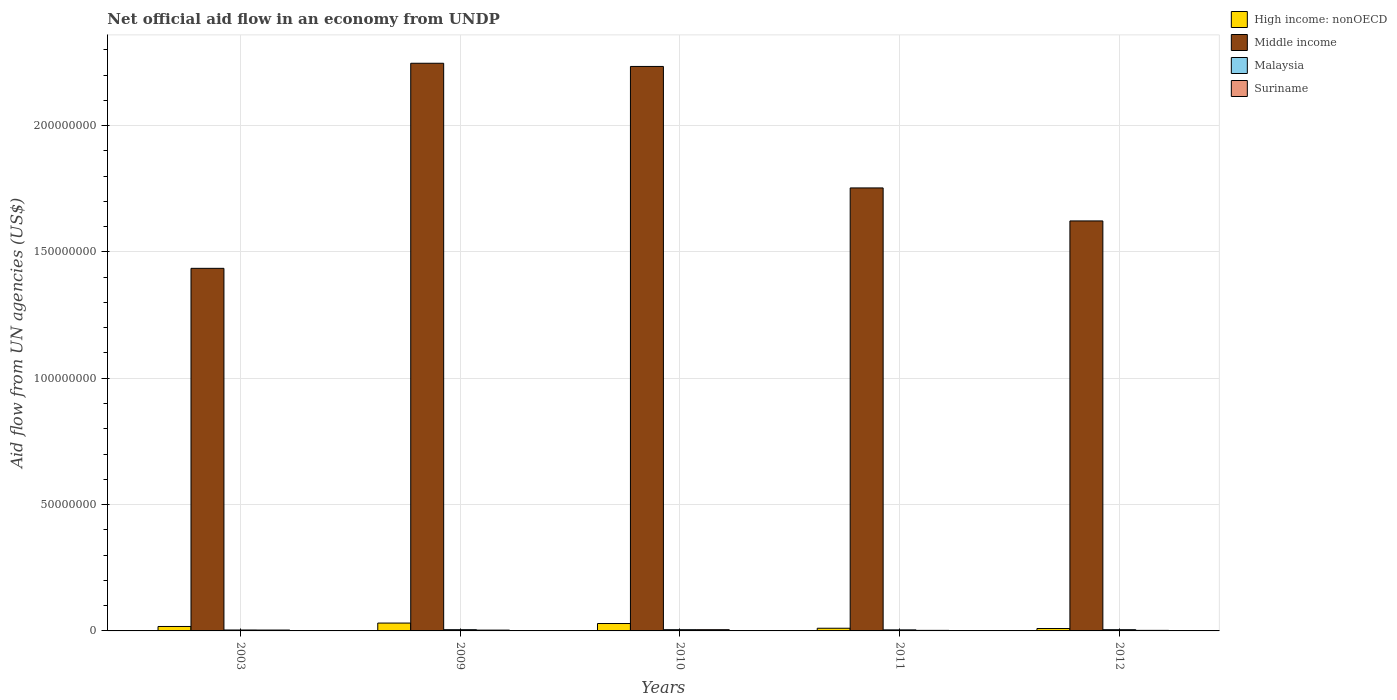How many different coloured bars are there?
Your answer should be very brief. 4. How many groups of bars are there?
Provide a succinct answer. 5. How many bars are there on the 2nd tick from the left?
Provide a short and direct response. 4. How many bars are there on the 1st tick from the right?
Provide a short and direct response. 4. What is the net official aid flow in High income: nonOECD in 2011?
Offer a very short reply. 1.06e+06. Across all years, what is the maximum net official aid flow in Middle income?
Offer a very short reply. 2.25e+08. Across all years, what is the minimum net official aid flow in Middle income?
Ensure brevity in your answer.  1.44e+08. In which year was the net official aid flow in High income: nonOECD minimum?
Your answer should be very brief. 2012. What is the total net official aid flow in Suriname in the graph?
Offer a very short reply. 1.59e+06. What is the difference between the net official aid flow in Suriname in 2011 and that in 2012?
Your answer should be compact. 0. What is the average net official aid flow in Suriname per year?
Your answer should be very brief. 3.18e+05. In the year 2003, what is the difference between the net official aid flow in Suriname and net official aid flow in Middle income?
Your answer should be compact. -1.43e+08. What is the ratio of the net official aid flow in High income: nonOECD in 2003 to that in 2010?
Your response must be concise. 0.6. Is the net official aid flow in Malaysia in 2003 less than that in 2009?
Offer a very short reply. Yes. Is the difference between the net official aid flow in Suriname in 2011 and 2012 greater than the difference between the net official aid flow in Middle income in 2011 and 2012?
Your answer should be very brief. No. What is the difference between the highest and the second highest net official aid flow in Middle income?
Ensure brevity in your answer.  1.26e+06. What is the difference between the highest and the lowest net official aid flow in Middle income?
Offer a terse response. 8.12e+07. In how many years, is the net official aid flow in Middle income greater than the average net official aid flow in Middle income taken over all years?
Ensure brevity in your answer.  2. Is the sum of the net official aid flow in Suriname in 2009 and 2011 greater than the maximum net official aid flow in Malaysia across all years?
Give a very brief answer. Yes. What does the 1st bar from the left in 2010 represents?
Offer a terse response. High income: nonOECD. What does the 2nd bar from the right in 2012 represents?
Make the answer very short. Malaysia. Is it the case that in every year, the sum of the net official aid flow in Suriname and net official aid flow in Middle income is greater than the net official aid flow in Malaysia?
Your answer should be very brief. Yes. Are all the bars in the graph horizontal?
Offer a very short reply. No. Are the values on the major ticks of Y-axis written in scientific E-notation?
Ensure brevity in your answer.  No. Does the graph contain any zero values?
Your response must be concise. No. How many legend labels are there?
Give a very brief answer. 4. How are the legend labels stacked?
Keep it short and to the point. Vertical. What is the title of the graph?
Give a very brief answer. Net official aid flow in an economy from UNDP. Does "Ireland" appear as one of the legend labels in the graph?
Your answer should be compact. No. What is the label or title of the Y-axis?
Provide a short and direct response. Aid flow from UN agencies (US$). What is the Aid flow from UN agencies (US$) in High income: nonOECD in 2003?
Provide a short and direct response. 1.76e+06. What is the Aid flow from UN agencies (US$) in Middle income in 2003?
Ensure brevity in your answer.  1.44e+08. What is the Aid flow from UN agencies (US$) in Suriname in 2003?
Make the answer very short. 3.40e+05. What is the Aid flow from UN agencies (US$) of High income: nonOECD in 2009?
Your answer should be very brief. 3.11e+06. What is the Aid flow from UN agencies (US$) in Middle income in 2009?
Keep it short and to the point. 2.25e+08. What is the Aid flow from UN agencies (US$) of Suriname in 2009?
Provide a succinct answer. 3.20e+05. What is the Aid flow from UN agencies (US$) of High income: nonOECD in 2010?
Provide a succinct answer. 2.93e+06. What is the Aid flow from UN agencies (US$) of Middle income in 2010?
Offer a terse response. 2.23e+08. What is the Aid flow from UN agencies (US$) of Malaysia in 2010?
Your answer should be compact. 4.90e+05. What is the Aid flow from UN agencies (US$) in Suriname in 2010?
Keep it short and to the point. 4.90e+05. What is the Aid flow from UN agencies (US$) of High income: nonOECD in 2011?
Keep it short and to the point. 1.06e+06. What is the Aid flow from UN agencies (US$) of Middle income in 2011?
Offer a very short reply. 1.75e+08. What is the Aid flow from UN agencies (US$) of Malaysia in 2011?
Provide a succinct answer. 4.20e+05. What is the Aid flow from UN agencies (US$) of High income: nonOECD in 2012?
Give a very brief answer. 9.50e+05. What is the Aid flow from UN agencies (US$) in Middle income in 2012?
Keep it short and to the point. 1.62e+08. Across all years, what is the maximum Aid flow from UN agencies (US$) in High income: nonOECD?
Keep it short and to the point. 3.11e+06. Across all years, what is the maximum Aid flow from UN agencies (US$) in Middle income?
Provide a succinct answer. 2.25e+08. Across all years, what is the maximum Aid flow from UN agencies (US$) of Malaysia?
Offer a very short reply. 4.90e+05. Across all years, what is the maximum Aid flow from UN agencies (US$) of Suriname?
Your answer should be very brief. 4.90e+05. Across all years, what is the minimum Aid flow from UN agencies (US$) of High income: nonOECD?
Provide a short and direct response. 9.50e+05. Across all years, what is the minimum Aid flow from UN agencies (US$) in Middle income?
Keep it short and to the point. 1.44e+08. Across all years, what is the minimum Aid flow from UN agencies (US$) in Malaysia?
Your response must be concise. 3.70e+05. What is the total Aid flow from UN agencies (US$) in High income: nonOECD in the graph?
Provide a short and direct response. 9.81e+06. What is the total Aid flow from UN agencies (US$) of Middle income in the graph?
Provide a succinct answer. 9.29e+08. What is the total Aid flow from UN agencies (US$) in Malaysia in the graph?
Give a very brief answer. 2.26e+06. What is the total Aid flow from UN agencies (US$) in Suriname in the graph?
Ensure brevity in your answer.  1.59e+06. What is the difference between the Aid flow from UN agencies (US$) of High income: nonOECD in 2003 and that in 2009?
Provide a short and direct response. -1.35e+06. What is the difference between the Aid flow from UN agencies (US$) of Middle income in 2003 and that in 2009?
Offer a very short reply. -8.12e+07. What is the difference between the Aid flow from UN agencies (US$) in Suriname in 2003 and that in 2009?
Keep it short and to the point. 2.00e+04. What is the difference between the Aid flow from UN agencies (US$) in High income: nonOECD in 2003 and that in 2010?
Provide a succinct answer. -1.17e+06. What is the difference between the Aid flow from UN agencies (US$) of Middle income in 2003 and that in 2010?
Provide a succinct answer. -7.99e+07. What is the difference between the Aid flow from UN agencies (US$) in Malaysia in 2003 and that in 2010?
Provide a short and direct response. -1.20e+05. What is the difference between the Aid flow from UN agencies (US$) in Middle income in 2003 and that in 2011?
Your response must be concise. -3.18e+07. What is the difference between the Aid flow from UN agencies (US$) in Malaysia in 2003 and that in 2011?
Make the answer very short. -5.00e+04. What is the difference between the Aid flow from UN agencies (US$) of Suriname in 2003 and that in 2011?
Provide a short and direct response. 1.20e+05. What is the difference between the Aid flow from UN agencies (US$) of High income: nonOECD in 2003 and that in 2012?
Your answer should be compact. 8.10e+05. What is the difference between the Aid flow from UN agencies (US$) of Middle income in 2003 and that in 2012?
Provide a succinct answer. -1.88e+07. What is the difference between the Aid flow from UN agencies (US$) in Malaysia in 2003 and that in 2012?
Give a very brief answer. -1.20e+05. What is the difference between the Aid flow from UN agencies (US$) of Suriname in 2003 and that in 2012?
Your answer should be very brief. 1.20e+05. What is the difference between the Aid flow from UN agencies (US$) in High income: nonOECD in 2009 and that in 2010?
Your answer should be compact. 1.80e+05. What is the difference between the Aid flow from UN agencies (US$) of Middle income in 2009 and that in 2010?
Make the answer very short. 1.26e+06. What is the difference between the Aid flow from UN agencies (US$) of Suriname in 2009 and that in 2010?
Offer a terse response. -1.70e+05. What is the difference between the Aid flow from UN agencies (US$) in High income: nonOECD in 2009 and that in 2011?
Provide a short and direct response. 2.05e+06. What is the difference between the Aid flow from UN agencies (US$) in Middle income in 2009 and that in 2011?
Make the answer very short. 4.93e+07. What is the difference between the Aid flow from UN agencies (US$) in Malaysia in 2009 and that in 2011?
Keep it short and to the point. 7.00e+04. What is the difference between the Aid flow from UN agencies (US$) in Suriname in 2009 and that in 2011?
Offer a terse response. 1.00e+05. What is the difference between the Aid flow from UN agencies (US$) in High income: nonOECD in 2009 and that in 2012?
Provide a succinct answer. 2.16e+06. What is the difference between the Aid flow from UN agencies (US$) in Middle income in 2009 and that in 2012?
Ensure brevity in your answer.  6.24e+07. What is the difference between the Aid flow from UN agencies (US$) of Malaysia in 2009 and that in 2012?
Offer a very short reply. 0. What is the difference between the Aid flow from UN agencies (US$) of Suriname in 2009 and that in 2012?
Provide a succinct answer. 1.00e+05. What is the difference between the Aid flow from UN agencies (US$) of High income: nonOECD in 2010 and that in 2011?
Provide a succinct answer. 1.87e+06. What is the difference between the Aid flow from UN agencies (US$) in Middle income in 2010 and that in 2011?
Provide a succinct answer. 4.81e+07. What is the difference between the Aid flow from UN agencies (US$) of Malaysia in 2010 and that in 2011?
Offer a terse response. 7.00e+04. What is the difference between the Aid flow from UN agencies (US$) in High income: nonOECD in 2010 and that in 2012?
Ensure brevity in your answer.  1.98e+06. What is the difference between the Aid flow from UN agencies (US$) in Middle income in 2010 and that in 2012?
Provide a short and direct response. 6.11e+07. What is the difference between the Aid flow from UN agencies (US$) of Malaysia in 2010 and that in 2012?
Keep it short and to the point. 0. What is the difference between the Aid flow from UN agencies (US$) in Suriname in 2010 and that in 2012?
Keep it short and to the point. 2.70e+05. What is the difference between the Aid flow from UN agencies (US$) in Middle income in 2011 and that in 2012?
Your answer should be compact. 1.31e+07. What is the difference between the Aid flow from UN agencies (US$) in Malaysia in 2011 and that in 2012?
Ensure brevity in your answer.  -7.00e+04. What is the difference between the Aid flow from UN agencies (US$) of Suriname in 2011 and that in 2012?
Your response must be concise. 0. What is the difference between the Aid flow from UN agencies (US$) of High income: nonOECD in 2003 and the Aid flow from UN agencies (US$) of Middle income in 2009?
Provide a short and direct response. -2.23e+08. What is the difference between the Aid flow from UN agencies (US$) in High income: nonOECD in 2003 and the Aid flow from UN agencies (US$) in Malaysia in 2009?
Provide a succinct answer. 1.27e+06. What is the difference between the Aid flow from UN agencies (US$) of High income: nonOECD in 2003 and the Aid flow from UN agencies (US$) of Suriname in 2009?
Keep it short and to the point. 1.44e+06. What is the difference between the Aid flow from UN agencies (US$) of Middle income in 2003 and the Aid flow from UN agencies (US$) of Malaysia in 2009?
Offer a terse response. 1.43e+08. What is the difference between the Aid flow from UN agencies (US$) in Middle income in 2003 and the Aid flow from UN agencies (US$) in Suriname in 2009?
Give a very brief answer. 1.43e+08. What is the difference between the Aid flow from UN agencies (US$) of Malaysia in 2003 and the Aid flow from UN agencies (US$) of Suriname in 2009?
Provide a short and direct response. 5.00e+04. What is the difference between the Aid flow from UN agencies (US$) of High income: nonOECD in 2003 and the Aid flow from UN agencies (US$) of Middle income in 2010?
Provide a succinct answer. -2.22e+08. What is the difference between the Aid flow from UN agencies (US$) in High income: nonOECD in 2003 and the Aid flow from UN agencies (US$) in Malaysia in 2010?
Provide a succinct answer. 1.27e+06. What is the difference between the Aid flow from UN agencies (US$) in High income: nonOECD in 2003 and the Aid flow from UN agencies (US$) in Suriname in 2010?
Your response must be concise. 1.27e+06. What is the difference between the Aid flow from UN agencies (US$) of Middle income in 2003 and the Aid flow from UN agencies (US$) of Malaysia in 2010?
Provide a short and direct response. 1.43e+08. What is the difference between the Aid flow from UN agencies (US$) of Middle income in 2003 and the Aid flow from UN agencies (US$) of Suriname in 2010?
Offer a terse response. 1.43e+08. What is the difference between the Aid flow from UN agencies (US$) in Malaysia in 2003 and the Aid flow from UN agencies (US$) in Suriname in 2010?
Offer a terse response. -1.20e+05. What is the difference between the Aid flow from UN agencies (US$) in High income: nonOECD in 2003 and the Aid flow from UN agencies (US$) in Middle income in 2011?
Your response must be concise. -1.74e+08. What is the difference between the Aid flow from UN agencies (US$) of High income: nonOECD in 2003 and the Aid flow from UN agencies (US$) of Malaysia in 2011?
Offer a terse response. 1.34e+06. What is the difference between the Aid flow from UN agencies (US$) of High income: nonOECD in 2003 and the Aid flow from UN agencies (US$) of Suriname in 2011?
Offer a terse response. 1.54e+06. What is the difference between the Aid flow from UN agencies (US$) in Middle income in 2003 and the Aid flow from UN agencies (US$) in Malaysia in 2011?
Provide a succinct answer. 1.43e+08. What is the difference between the Aid flow from UN agencies (US$) in Middle income in 2003 and the Aid flow from UN agencies (US$) in Suriname in 2011?
Give a very brief answer. 1.43e+08. What is the difference between the Aid flow from UN agencies (US$) in High income: nonOECD in 2003 and the Aid flow from UN agencies (US$) in Middle income in 2012?
Make the answer very short. -1.60e+08. What is the difference between the Aid flow from UN agencies (US$) in High income: nonOECD in 2003 and the Aid flow from UN agencies (US$) in Malaysia in 2012?
Your response must be concise. 1.27e+06. What is the difference between the Aid flow from UN agencies (US$) in High income: nonOECD in 2003 and the Aid flow from UN agencies (US$) in Suriname in 2012?
Offer a terse response. 1.54e+06. What is the difference between the Aid flow from UN agencies (US$) in Middle income in 2003 and the Aid flow from UN agencies (US$) in Malaysia in 2012?
Provide a short and direct response. 1.43e+08. What is the difference between the Aid flow from UN agencies (US$) of Middle income in 2003 and the Aid flow from UN agencies (US$) of Suriname in 2012?
Offer a very short reply. 1.43e+08. What is the difference between the Aid flow from UN agencies (US$) of High income: nonOECD in 2009 and the Aid flow from UN agencies (US$) of Middle income in 2010?
Make the answer very short. -2.20e+08. What is the difference between the Aid flow from UN agencies (US$) of High income: nonOECD in 2009 and the Aid flow from UN agencies (US$) of Malaysia in 2010?
Your answer should be very brief. 2.62e+06. What is the difference between the Aid flow from UN agencies (US$) of High income: nonOECD in 2009 and the Aid flow from UN agencies (US$) of Suriname in 2010?
Offer a terse response. 2.62e+06. What is the difference between the Aid flow from UN agencies (US$) of Middle income in 2009 and the Aid flow from UN agencies (US$) of Malaysia in 2010?
Keep it short and to the point. 2.24e+08. What is the difference between the Aid flow from UN agencies (US$) of Middle income in 2009 and the Aid flow from UN agencies (US$) of Suriname in 2010?
Offer a very short reply. 2.24e+08. What is the difference between the Aid flow from UN agencies (US$) of High income: nonOECD in 2009 and the Aid flow from UN agencies (US$) of Middle income in 2011?
Offer a very short reply. -1.72e+08. What is the difference between the Aid flow from UN agencies (US$) of High income: nonOECD in 2009 and the Aid flow from UN agencies (US$) of Malaysia in 2011?
Provide a succinct answer. 2.69e+06. What is the difference between the Aid flow from UN agencies (US$) in High income: nonOECD in 2009 and the Aid flow from UN agencies (US$) in Suriname in 2011?
Your response must be concise. 2.89e+06. What is the difference between the Aid flow from UN agencies (US$) in Middle income in 2009 and the Aid flow from UN agencies (US$) in Malaysia in 2011?
Offer a terse response. 2.24e+08. What is the difference between the Aid flow from UN agencies (US$) in Middle income in 2009 and the Aid flow from UN agencies (US$) in Suriname in 2011?
Offer a terse response. 2.24e+08. What is the difference between the Aid flow from UN agencies (US$) in High income: nonOECD in 2009 and the Aid flow from UN agencies (US$) in Middle income in 2012?
Offer a very short reply. -1.59e+08. What is the difference between the Aid flow from UN agencies (US$) of High income: nonOECD in 2009 and the Aid flow from UN agencies (US$) of Malaysia in 2012?
Your response must be concise. 2.62e+06. What is the difference between the Aid flow from UN agencies (US$) of High income: nonOECD in 2009 and the Aid flow from UN agencies (US$) of Suriname in 2012?
Provide a short and direct response. 2.89e+06. What is the difference between the Aid flow from UN agencies (US$) in Middle income in 2009 and the Aid flow from UN agencies (US$) in Malaysia in 2012?
Provide a succinct answer. 2.24e+08. What is the difference between the Aid flow from UN agencies (US$) of Middle income in 2009 and the Aid flow from UN agencies (US$) of Suriname in 2012?
Your answer should be very brief. 2.24e+08. What is the difference between the Aid flow from UN agencies (US$) of High income: nonOECD in 2010 and the Aid flow from UN agencies (US$) of Middle income in 2011?
Make the answer very short. -1.72e+08. What is the difference between the Aid flow from UN agencies (US$) of High income: nonOECD in 2010 and the Aid flow from UN agencies (US$) of Malaysia in 2011?
Give a very brief answer. 2.51e+06. What is the difference between the Aid flow from UN agencies (US$) in High income: nonOECD in 2010 and the Aid flow from UN agencies (US$) in Suriname in 2011?
Make the answer very short. 2.71e+06. What is the difference between the Aid flow from UN agencies (US$) in Middle income in 2010 and the Aid flow from UN agencies (US$) in Malaysia in 2011?
Make the answer very short. 2.23e+08. What is the difference between the Aid flow from UN agencies (US$) in Middle income in 2010 and the Aid flow from UN agencies (US$) in Suriname in 2011?
Keep it short and to the point. 2.23e+08. What is the difference between the Aid flow from UN agencies (US$) of High income: nonOECD in 2010 and the Aid flow from UN agencies (US$) of Middle income in 2012?
Provide a short and direct response. -1.59e+08. What is the difference between the Aid flow from UN agencies (US$) in High income: nonOECD in 2010 and the Aid flow from UN agencies (US$) in Malaysia in 2012?
Give a very brief answer. 2.44e+06. What is the difference between the Aid flow from UN agencies (US$) of High income: nonOECD in 2010 and the Aid flow from UN agencies (US$) of Suriname in 2012?
Your answer should be compact. 2.71e+06. What is the difference between the Aid flow from UN agencies (US$) in Middle income in 2010 and the Aid flow from UN agencies (US$) in Malaysia in 2012?
Provide a short and direct response. 2.23e+08. What is the difference between the Aid flow from UN agencies (US$) in Middle income in 2010 and the Aid flow from UN agencies (US$) in Suriname in 2012?
Give a very brief answer. 2.23e+08. What is the difference between the Aid flow from UN agencies (US$) of Malaysia in 2010 and the Aid flow from UN agencies (US$) of Suriname in 2012?
Offer a terse response. 2.70e+05. What is the difference between the Aid flow from UN agencies (US$) of High income: nonOECD in 2011 and the Aid flow from UN agencies (US$) of Middle income in 2012?
Give a very brief answer. -1.61e+08. What is the difference between the Aid flow from UN agencies (US$) in High income: nonOECD in 2011 and the Aid flow from UN agencies (US$) in Malaysia in 2012?
Offer a very short reply. 5.70e+05. What is the difference between the Aid flow from UN agencies (US$) in High income: nonOECD in 2011 and the Aid flow from UN agencies (US$) in Suriname in 2012?
Make the answer very short. 8.40e+05. What is the difference between the Aid flow from UN agencies (US$) in Middle income in 2011 and the Aid flow from UN agencies (US$) in Malaysia in 2012?
Your answer should be compact. 1.75e+08. What is the difference between the Aid flow from UN agencies (US$) in Middle income in 2011 and the Aid flow from UN agencies (US$) in Suriname in 2012?
Give a very brief answer. 1.75e+08. What is the difference between the Aid flow from UN agencies (US$) of Malaysia in 2011 and the Aid flow from UN agencies (US$) of Suriname in 2012?
Ensure brevity in your answer.  2.00e+05. What is the average Aid flow from UN agencies (US$) in High income: nonOECD per year?
Keep it short and to the point. 1.96e+06. What is the average Aid flow from UN agencies (US$) of Middle income per year?
Provide a short and direct response. 1.86e+08. What is the average Aid flow from UN agencies (US$) in Malaysia per year?
Provide a succinct answer. 4.52e+05. What is the average Aid flow from UN agencies (US$) in Suriname per year?
Provide a succinct answer. 3.18e+05. In the year 2003, what is the difference between the Aid flow from UN agencies (US$) in High income: nonOECD and Aid flow from UN agencies (US$) in Middle income?
Your answer should be compact. -1.42e+08. In the year 2003, what is the difference between the Aid flow from UN agencies (US$) in High income: nonOECD and Aid flow from UN agencies (US$) in Malaysia?
Give a very brief answer. 1.39e+06. In the year 2003, what is the difference between the Aid flow from UN agencies (US$) of High income: nonOECD and Aid flow from UN agencies (US$) of Suriname?
Offer a terse response. 1.42e+06. In the year 2003, what is the difference between the Aid flow from UN agencies (US$) of Middle income and Aid flow from UN agencies (US$) of Malaysia?
Make the answer very short. 1.43e+08. In the year 2003, what is the difference between the Aid flow from UN agencies (US$) of Middle income and Aid flow from UN agencies (US$) of Suriname?
Make the answer very short. 1.43e+08. In the year 2009, what is the difference between the Aid flow from UN agencies (US$) of High income: nonOECD and Aid flow from UN agencies (US$) of Middle income?
Offer a very short reply. -2.22e+08. In the year 2009, what is the difference between the Aid flow from UN agencies (US$) in High income: nonOECD and Aid flow from UN agencies (US$) in Malaysia?
Make the answer very short. 2.62e+06. In the year 2009, what is the difference between the Aid flow from UN agencies (US$) of High income: nonOECD and Aid flow from UN agencies (US$) of Suriname?
Provide a short and direct response. 2.79e+06. In the year 2009, what is the difference between the Aid flow from UN agencies (US$) of Middle income and Aid flow from UN agencies (US$) of Malaysia?
Give a very brief answer. 2.24e+08. In the year 2009, what is the difference between the Aid flow from UN agencies (US$) of Middle income and Aid flow from UN agencies (US$) of Suriname?
Your answer should be very brief. 2.24e+08. In the year 2009, what is the difference between the Aid flow from UN agencies (US$) of Malaysia and Aid flow from UN agencies (US$) of Suriname?
Keep it short and to the point. 1.70e+05. In the year 2010, what is the difference between the Aid flow from UN agencies (US$) of High income: nonOECD and Aid flow from UN agencies (US$) of Middle income?
Provide a short and direct response. -2.20e+08. In the year 2010, what is the difference between the Aid flow from UN agencies (US$) of High income: nonOECD and Aid flow from UN agencies (US$) of Malaysia?
Your response must be concise. 2.44e+06. In the year 2010, what is the difference between the Aid flow from UN agencies (US$) in High income: nonOECD and Aid flow from UN agencies (US$) in Suriname?
Give a very brief answer. 2.44e+06. In the year 2010, what is the difference between the Aid flow from UN agencies (US$) in Middle income and Aid flow from UN agencies (US$) in Malaysia?
Offer a very short reply. 2.23e+08. In the year 2010, what is the difference between the Aid flow from UN agencies (US$) in Middle income and Aid flow from UN agencies (US$) in Suriname?
Offer a terse response. 2.23e+08. In the year 2010, what is the difference between the Aid flow from UN agencies (US$) in Malaysia and Aid flow from UN agencies (US$) in Suriname?
Provide a succinct answer. 0. In the year 2011, what is the difference between the Aid flow from UN agencies (US$) of High income: nonOECD and Aid flow from UN agencies (US$) of Middle income?
Keep it short and to the point. -1.74e+08. In the year 2011, what is the difference between the Aid flow from UN agencies (US$) of High income: nonOECD and Aid flow from UN agencies (US$) of Malaysia?
Your answer should be very brief. 6.40e+05. In the year 2011, what is the difference between the Aid flow from UN agencies (US$) of High income: nonOECD and Aid flow from UN agencies (US$) of Suriname?
Keep it short and to the point. 8.40e+05. In the year 2011, what is the difference between the Aid flow from UN agencies (US$) of Middle income and Aid flow from UN agencies (US$) of Malaysia?
Provide a short and direct response. 1.75e+08. In the year 2011, what is the difference between the Aid flow from UN agencies (US$) of Middle income and Aid flow from UN agencies (US$) of Suriname?
Offer a terse response. 1.75e+08. In the year 2011, what is the difference between the Aid flow from UN agencies (US$) of Malaysia and Aid flow from UN agencies (US$) of Suriname?
Offer a terse response. 2.00e+05. In the year 2012, what is the difference between the Aid flow from UN agencies (US$) of High income: nonOECD and Aid flow from UN agencies (US$) of Middle income?
Your answer should be very brief. -1.61e+08. In the year 2012, what is the difference between the Aid flow from UN agencies (US$) in High income: nonOECD and Aid flow from UN agencies (US$) in Suriname?
Ensure brevity in your answer.  7.30e+05. In the year 2012, what is the difference between the Aid flow from UN agencies (US$) in Middle income and Aid flow from UN agencies (US$) in Malaysia?
Provide a short and direct response. 1.62e+08. In the year 2012, what is the difference between the Aid flow from UN agencies (US$) of Middle income and Aid flow from UN agencies (US$) of Suriname?
Ensure brevity in your answer.  1.62e+08. What is the ratio of the Aid flow from UN agencies (US$) in High income: nonOECD in 2003 to that in 2009?
Give a very brief answer. 0.57. What is the ratio of the Aid flow from UN agencies (US$) in Middle income in 2003 to that in 2009?
Keep it short and to the point. 0.64. What is the ratio of the Aid flow from UN agencies (US$) in Malaysia in 2003 to that in 2009?
Your response must be concise. 0.76. What is the ratio of the Aid flow from UN agencies (US$) of Suriname in 2003 to that in 2009?
Keep it short and to the point. 1.06. What is the ratio of the Aid flow from UN agencies (US$) in High income: nonOECD in 2003 to that in 2010?
Provide a short and direct response. 0.6. What is the ratio of the Aid flow from UN agencies (US$) of Middle income in 2003 to that in 2010?
Ensure brevity in your answer.  0.64. What is the ratio of the Aid flow from UN agencies (US$) of Malaysia in 2003 to that in 2010?
Provide a succinct answer. 0.76. What is the ratio of the Aid flow from UN agencies (US$) in Suriname in 2003 to that in 2010?
Your answer should be very brief. 0.69. What is the ratio of the Aid flow from UN agencies (US$) in High income: nonOECD in 2003 to that in 2011?
Offer a very short reply. 1.66. What is the ratio of the Aid flow from UN agencies (US$) in Middle income in 2003 to that in 2011?
Provide a succinct answer. 0.82. What is the ratio of the Aid flow from UN agencies (US$) in Malaysia in 2003 to that in 2011?
Your response must be concise. 0.88. What is the ratio of the Aid flow from UN agencies (US$) of Suriname in 2003 to that in 2011?
Provide a short and direct response. 1.55. What is the ratio of the Aid flow from UN agencies (US$) of High income: nonOECD in 2003 to that in 2012?
Your answer should be compact. 1.85. What is the ratio of the Aid flow from UN agencies (US$) of Middle income in 2003 to that in 2012?
Your answer should be very brief. 0.88. What is the ratio of the Aid flow from UN agencies (US$) in Malaysia in 2003 to that in 2012?
Your response must be concise. 0.76. What is the ratio of the Aid flow from UN agencies (US$) in Suriname in 2003 to that in 2012?
Make the answer very short. 1.55. What is the ratio of the Aid flow from UN agencies (US$) of High income: nonOECD in 2009 to that in 2010?
Offer a very short reply. 1.06. What is the ratio of the Aid flow from UN agencies (US$) of Middle income in 2009 to that in 2010?
Provide a succinct answer. 1.01. What is the ratio of the Aid flow from UN agencies (US$) in Suriname in 2009 to that in 2010?
Give a very brief answer. 0.65. What is the ratio of the Aid flow from UN agencies (US$) in High income: nonOECD in 2009 to that in 2011?
Ensure brevity in your answer.  2.93. What is the ratio of the Aid flow from UN agencies (US$) in Middle income in 2009 to that in 2011?
Keep it short and to the point. 1.28. What is the ratio of the Aid flow from UN agencies (US$) of Suriname in 2009 to that in 2011?
Your answer should be compact. 1.45. What is the ratio of the Aid flow from UN agencies (US$) in High income: nonOECD in 2009 to that in 2012?
Your response must be concise. 3.27. What is the ratio of the Aid flow from UN agencies (US$) of Middle income in 2009 to that in 2012?
Your answer should be compact. 1.38. What is the ratio of the Aid flow from UN agencies (US$) in Suriname in 2009 to that in 2012?
Your answer should be very brief. 1.45. What is the ratio of the Aid flow from UN agencies (US$) of High income: nonOECD in 2010 to that in 2011?
Give a very brief answer. 2.76. What is the ratio of the Aid flow from UN agencies (US$) of Middle income in 2010 to that in 2011?
Your response must be concise. 1.27. What is the ratio of the Aid flow from UN agencies (US$) in Suriname in 2010 to that in 2011?
Provide a succinct answer. 2.23. What is the ratio of the Aid flow from UN agencies (US$) in High income: nonOECD in 2010 to that in 2012?
Keep it short and to the point. 3.08. What is the ratio of the Aid flow from UN agencies (US$) of Middle income in 2010 to that in 2012?
Give a very brief answer. 1.38. What is the ratio of the Aid flow from UN agencies (US$) in Malaysia in 2010 to that in 2012?
Provide a short and direct response. 1. What is the ratio of the Aid flow from UN agencies (US$) of Suriname in 2010 to that in 2012?
Make the answer very short. 2.23. What is the ratio of the Aid flow from UN agencies (US$) in High income: nonOECD in 2011 to that in 2012?
Your response must be concise. 1.12. What is the ratio of the Aid flow from UN agencies (US$) in Middle income in 2011 to that in 2012?
Offer a terse response. 1.08. What is the difference between the highest and the second highest Aid flow from UN agencies (US$) of High income: nonOECD?
Keep it short and to the point. 1.80e+05. What is the difference between the highest and the second highest Aid flow from UN agencies (US$) of Middle income?
Your response must be concise. 1.26e+06. What is the difference between the highest and the second highest Aid flow from UN agencies (US$) in Malaysia?
Your response must be concise. 0. What is the difference between the highest and the second highest Aid flow from UN agencies (US$) of Suriname?
Offer a terse response. 1.50e+05. What is the difference between the highest and the lowest Aid flow from UN agencies (US$) in High income: nonOECD?
Provide a succinct answer. 2.16e+06. What is the difference between the highest and the lowest Aid flow from UN agencies (US$) of Middle income?
Your answer should be very brief. 8.12e+07. 